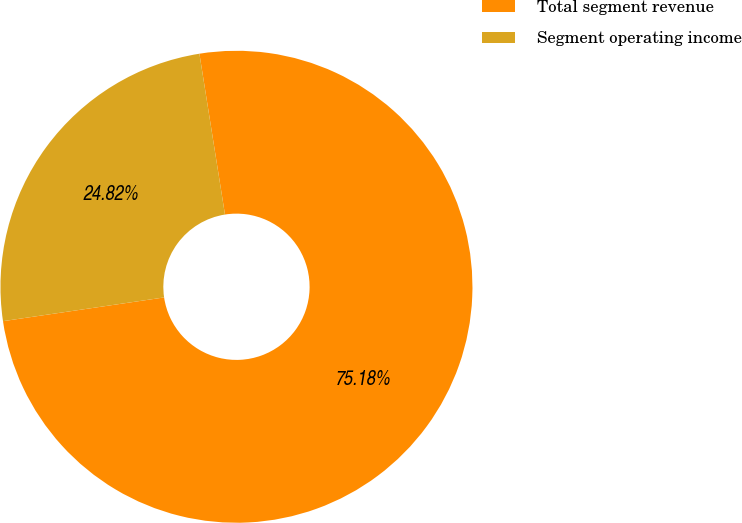<chart> <loc_0><loc_0><loc_500><loc_500><pie_chart><fcel>Total segment revenue<fcel>Segment operating income<nl><fcel>75.18%<fcel>24.82%<nl></chart> 